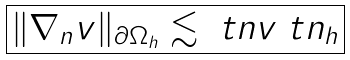Convert formula to latex. <formula><loc_0><loc_0><loc_500><loc_500>\boxed { \| \nabla _ { n } v \| _ { \partial \Omega _ { h } } \lesssim \ t n v \ t n _ { h } }</formula> 